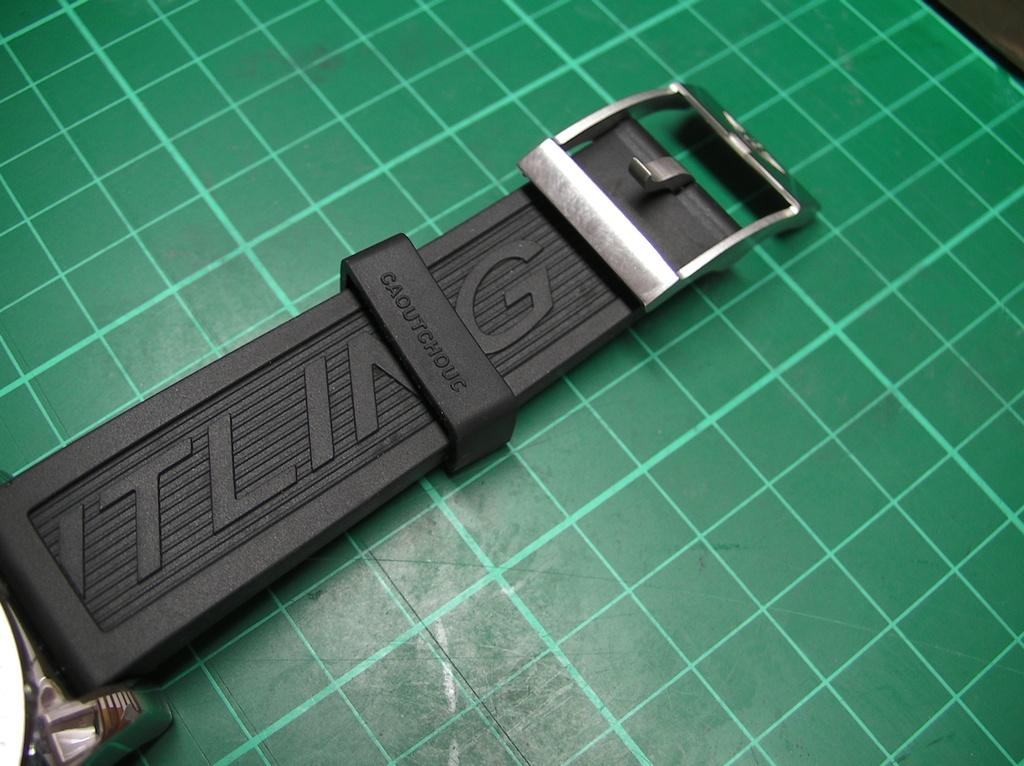<image>
Give a short and clear explanation of the subsequent image. A black strap with the word caoutchouc on it. 